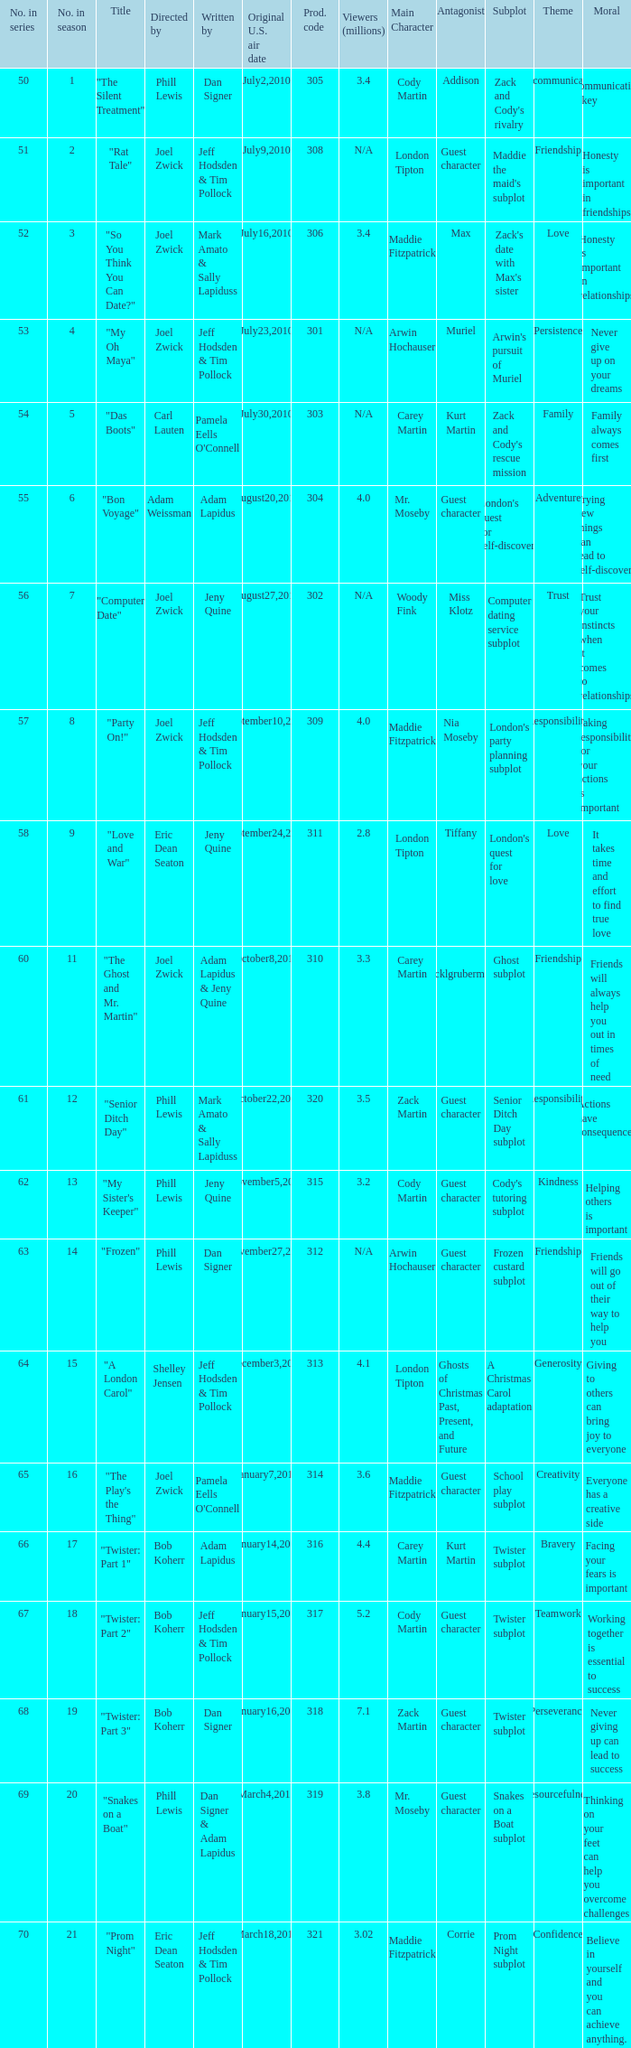What episode number was titled "my oh maya"? 4.0. 